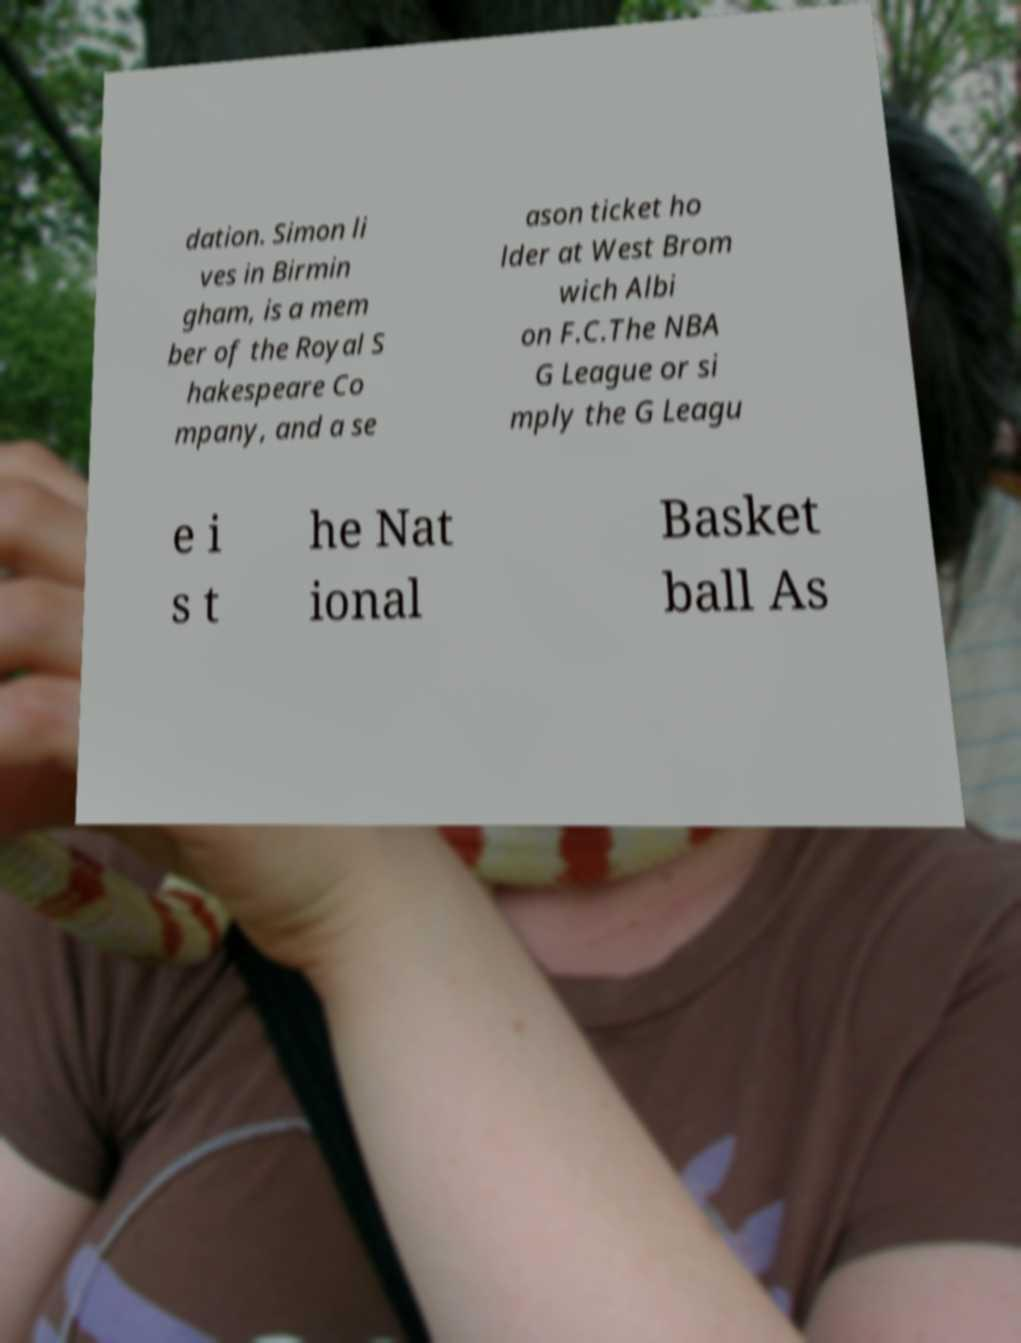Can you read and provide the text displayed in the image?This photo seems to have some interesting text. Can you extract and type it out for me? dation. Simon li ves in Birmin gham, is a mem ber of the Royal S hakespeare Co mpany, and a se ason ticket ho lder at West Brom wich Albi on F.C.The NBA G League or si mply the G Leagu e i s t he Nat ional Basket ball As 